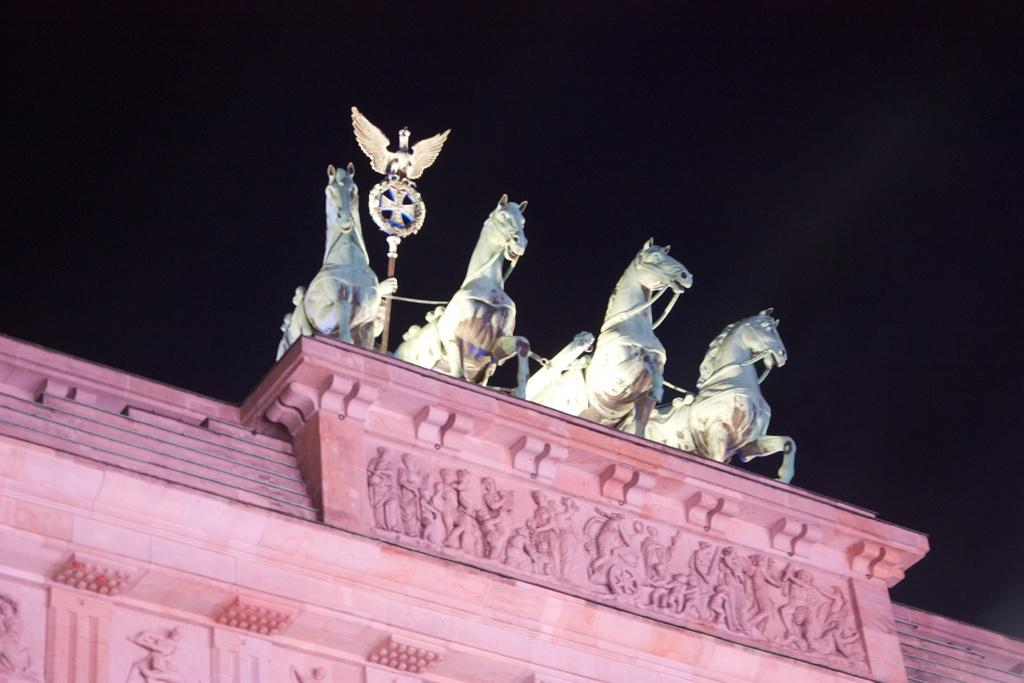What type of structure is present in the image? There is a building in the image. What additional objects can be seen in the image? There are statues of horses in the image. What type of rice is being cooked in the image? There is no rice present in the image. Is there a copy of the building in the image? There is no copy of the building in the image; only one building is visible. 